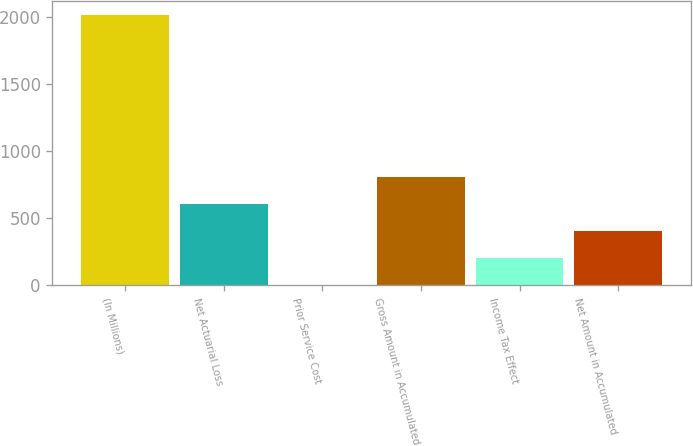Convert chart to OTSL. <chart><loc_0><loc_0><loc_500><loc_500><bar_chart><fcel>(In Millions)<fcel>Net Actuarial Loss<fcel>Prior Service Cost<fcel>Gross Amount in Accumulated<fcel>Income Tax Effect<fcel>Net Amount in Accumulated<nl><fcel>2018<fcel>605.68<fcel>0.4<fcel>807.44<fcel>202.16<fcel>403.92<nl></chart> 